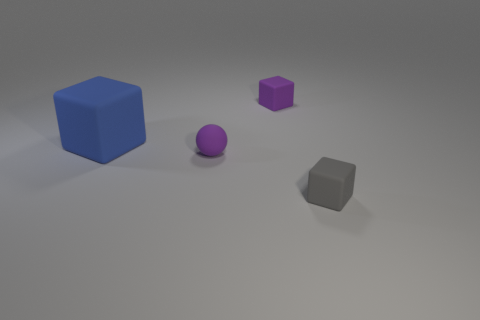What can you tell me about the lighting in this scene? The scene is lit from above, creating soft shadows beneath the objects which suggest the presence of a diffuse or possibly ambient light source, giving the setup a calm and evenly lit appearance. 